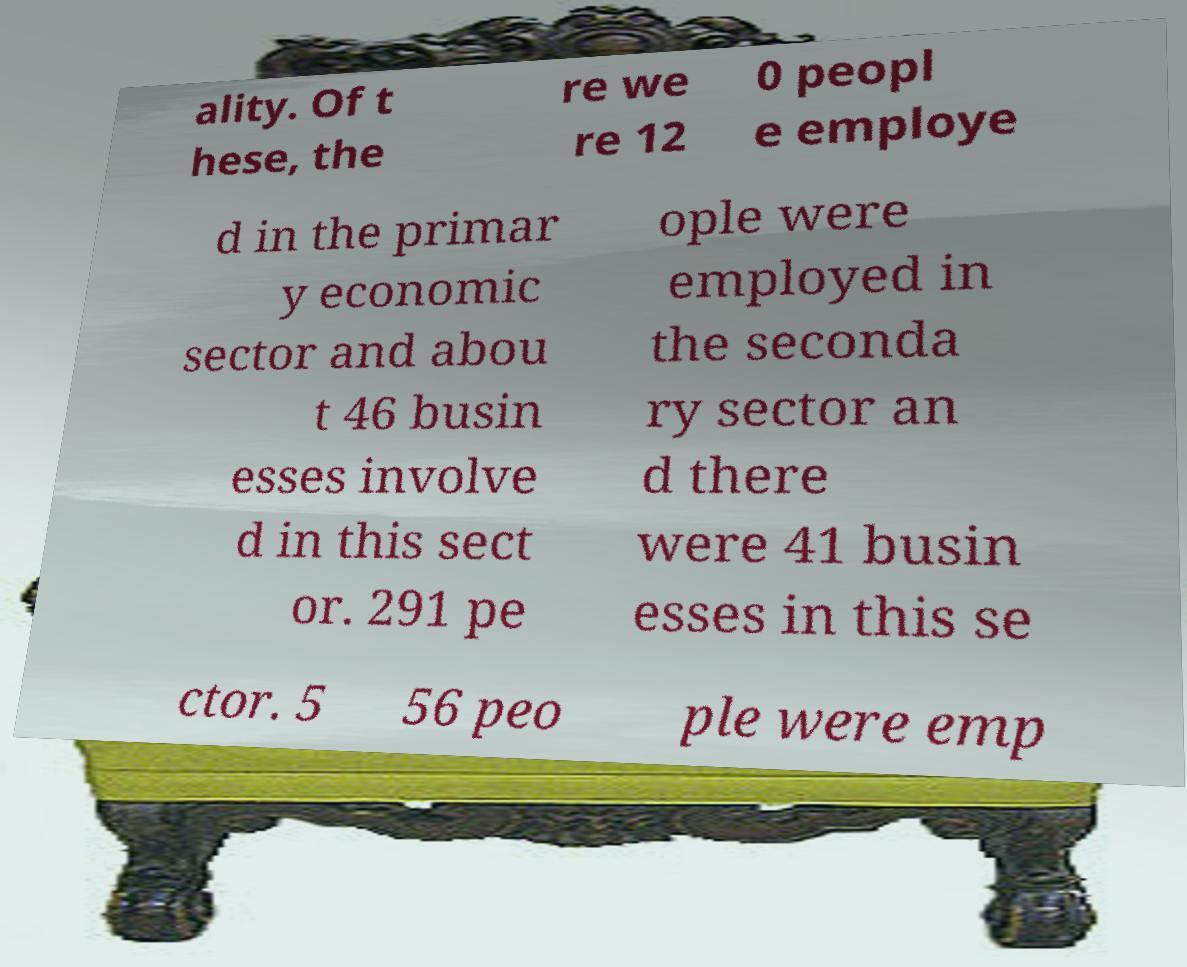Can you accurately transcribe the text from the provided image for me? ality. Of t hese, the re we re 12 0 peopl e employe d in the primar y economic sector and abou t 46 busin esses involve d in this sect or. 291 pe ople were employed in the seconda ry sector an d there were 41 busin esses in this se ctor. 5 56 peo ple were emp 